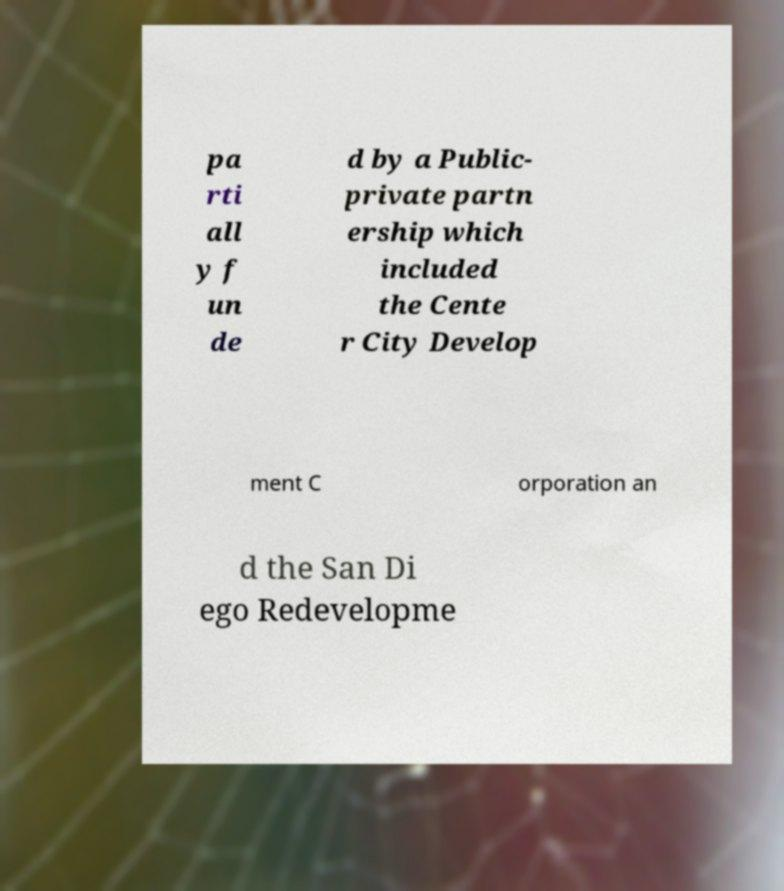For documentation purposes, I need the text within this image transcribed. Could you provide that? pa rti all y f un de d by a Public- private partn ership which included the Cente r City Develop ment C orporation an d the San Di ego Redevelopme 